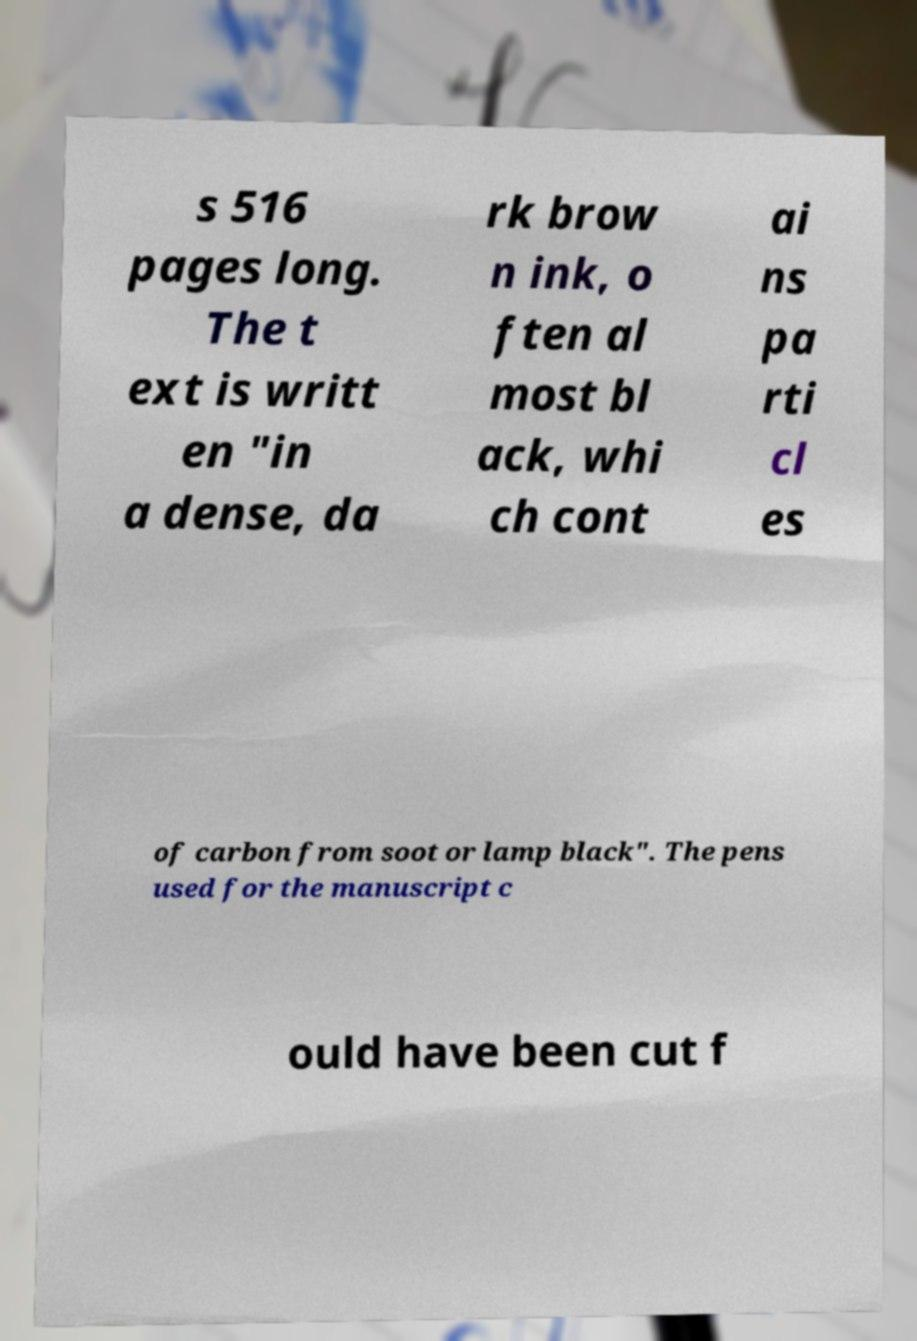Could you assist in decoding the text presented in this image and type it out clearly? s 516 pages long. The t ext is writt en "in a dense, da rk brow n ink, o ften al most bl ack, whi ch cont ai ns pa rti cl es of carbon from soot or lamp black". The pens used for the manuscript c ould have been cut f 